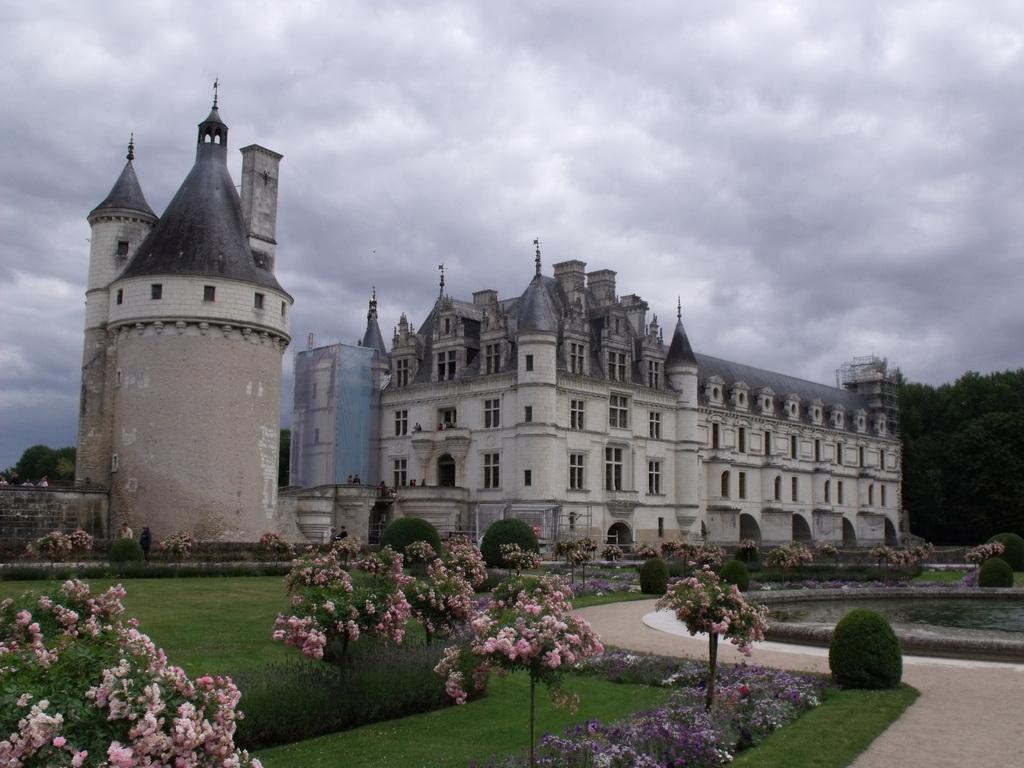How would you summarize this image in a sentence or two? In this picture we can see building and monument. At the bottom we can see plants, grass and street walk. On the left we can see trees. At the top we can see sky and clouds. At the bottom we can see flowers on the plants. 